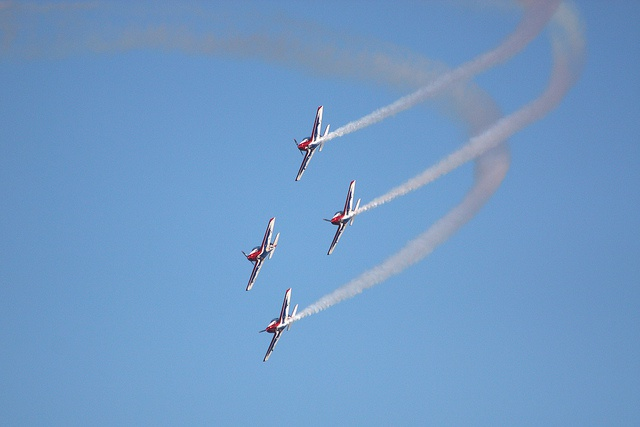Describe the objects in this image and their specific colors. I can see airplane in gray, lightblue, ivory, darkgray, and navy tones, airplane in gray, lightgray, darkgray, and navy tones, airplane in gray, white, darkgray, and navy tones, and airplane in gray, white, darkgray, and navy tones in this image. 